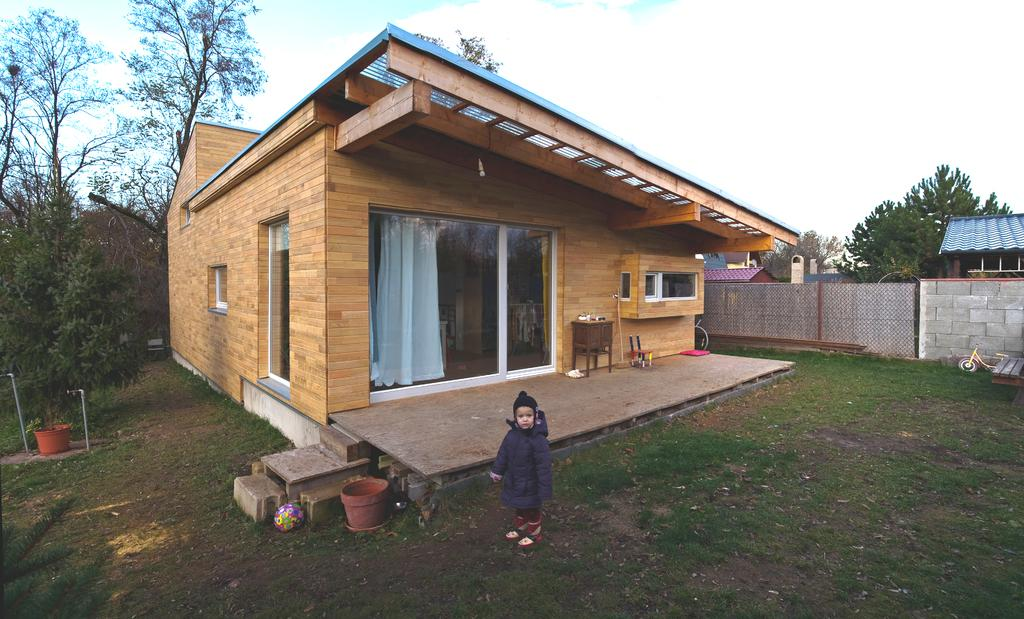What is the main subject in the image? There is a kid standing in the image. What type of terrain is visible in the image? There is grass visible in the image. What type of structure can be seen in the image? There is a house in the image. What are the poles used for in the image? The purpose of the poles is not specified in the image. What object is the kid holding in the image? There is a ball in the image, and the kid might be holding it. What mode of transportation is present in the image? There is a bicycle in the image. What type of barrier is visible in the image? There is a wall in the image. What type of containers are present in the image? There are pots in the image. What other objects can be seen in the image? There are objects in the image, but their specific nature is not mentioned. What can be seen in the background of the image? There are trees, houses, and sky visible in the background of the image. Where is the mother of the kid in the image? There is no mention of a mother in the image, so we cannot determine her location. What type of muscle is visible on the kid in the image? The image does not show any muscles, as it is a photograph of a kid standing. How many pigs are present in the image? There are no pigs present in the image. 